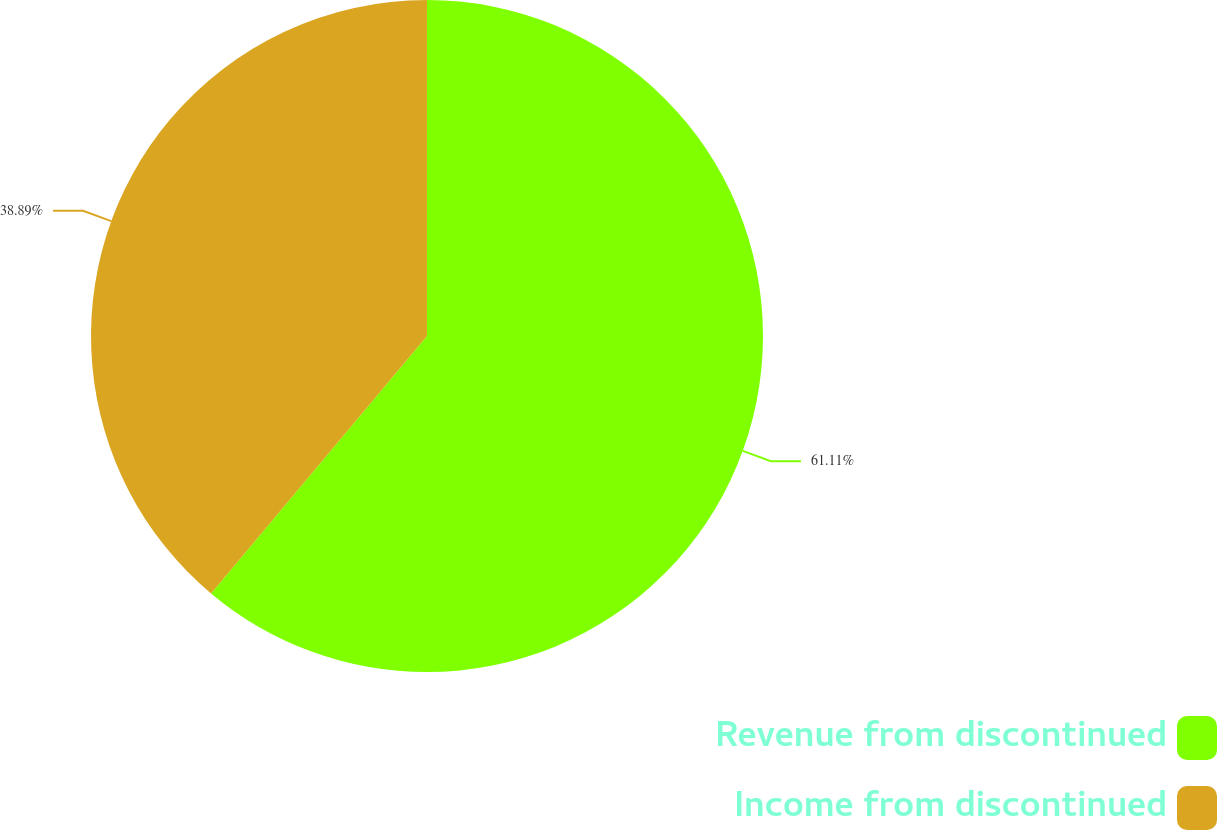<chart> <loc_0><loc_0><loc_500><loc_500><pie_chart><fcel>Revenue from discontinued<fcel>Income from discontinued<nl><fcel>61.11%<fcel>38.89%<nl></chart> 